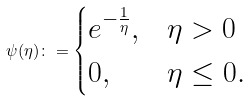<formula> <loc_0><loc_0><loc_500><loc_500>\psi ( \eta ) \colon = \begin{cases} e ^ { - \frac { 1 } { \eta } } , & \eta > 0 \\ 0 , & \eta \leq 0 . \end{cases}</formula> 